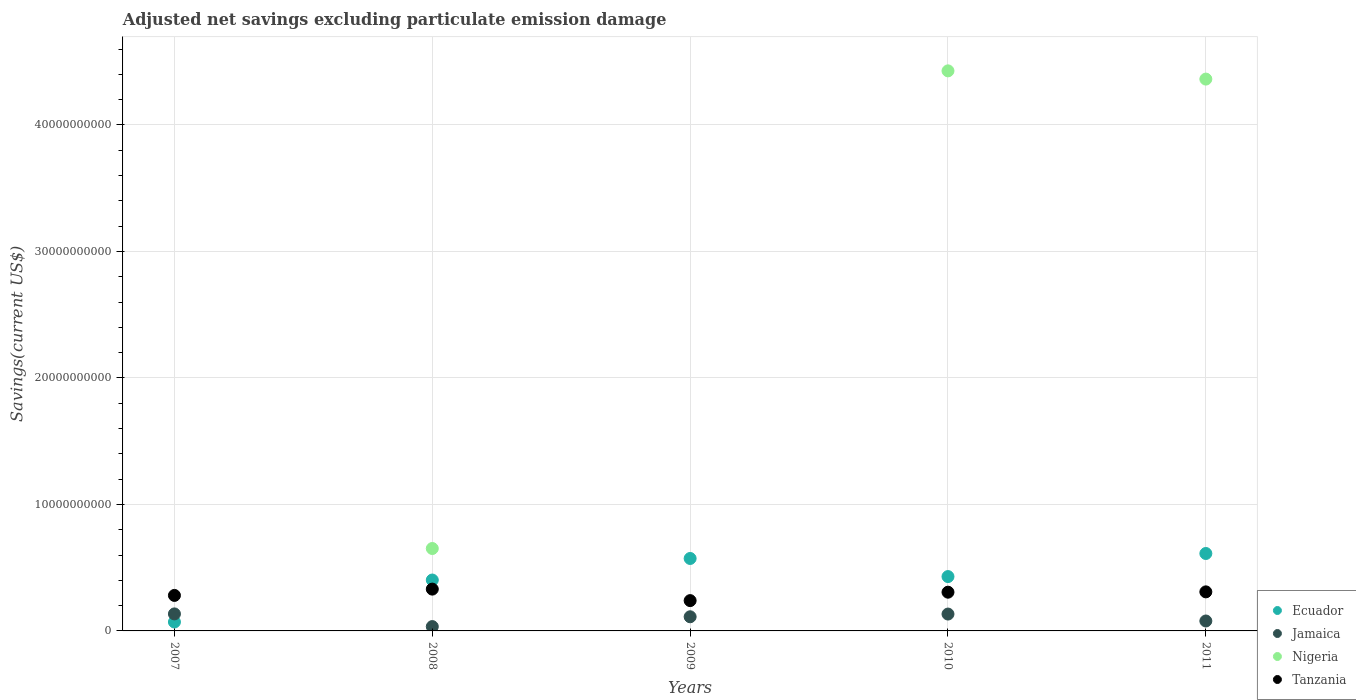Is the number of dotlines equal to the number of legend labels?
Provide a succinct answer. No. What is the adjusted net savings in Nigeria in 2011?
Make the answer very short. 4.36e+1. Across all years, what is the maximum adjusted net savings in Jamaica?
Provide a succinct answer. 1.34e+09. Across all years, what is the minimum adjusted net savings in Ecuador?
Offer a terse response. 7.05e+08. In which year was the adjusted net savings in Jamaica maximum?
Your answer should be very brief. 2007. What is the total adjusted net savings in Nigeria in the graph?
Provide a short and direct response. 9.44e+1. What is the difference between the adjusted net savings in Ecuador in 2009 and that in 2010?
Make the answer very short. 1.43e+09. What is the difference between the adjusted net savings in Ecuador in 2010 and the adjusted net savings in Tanzania in 2007?
Your answer should be very brief. 1.49e+09. What is the average adjusted net savings in Jamaica per year?
Your response must be concise. 9.85e+08. In the year 2011, what is the difference between the adjusted net savings in Tanzania and adjusted net savings in Nigeria?
Provide a short and direct response. -4.05e+1. In how many years, is the adjusted net savings in Jamaica greater than 6000000000 US$?
Provide a short and direct response. 0. What is the ratio of the adjusted net savings in Ecuador in 2007 to that in 2010?
Ensure brevity in your answer.  0.16. Is the difference between the adjusted net savings in Tanzania in 2010 and 2011 greater than the difference between the adjusted net savings in Nigeria in 2010 and 2011?
Provide a short and direct response. No. What is the difference between the highest and the second highest adjusted net savings in Jamaica?
Provide a short and direct response. 1.18e+07. What is the difference between the highest and the lowest adjusted net savings in Nigeria?
Provide a short and direct response. 4.43e+1. In how many years, is the adjusted net savings in Nigeria greater than the average adjusted net savings in Nigeria taken over all years?
Provide a short and direct response. 2. Is the sum of the adjusted net savings in Ecuador in 2007 and 2008 greater than the maximum adjusted net savings in Nigeria across all years?
Your response must be concise. No. Is it the case that in every year, the sum of the adjusted net savings in Ecuador and adjusted net savings in Jamaica  is greater than the adjusted net savings in Tanzania?
Make the answer very short. No. Does the adjusted net savings in Nigeria monotonically increase over the years?
Your response must be concise. No. Is the adjusted net savings in Tanzania strictly greater than the adjusted net savings in Jamaica over the years?
Provide a succinct answer. Yes. How many dotlines are there?
Keep it short and to the point. 4. What is the difference between two consecutive major ticks on the Y-axis?
Make the answer very short. 1.00e+1. Does the graph contain any zero values?
Keep it short and to the point. Yes. Does the graph contain grids?
Offer a terse response. Yes. Where does the legend appear in the graph?
Give a very brief answer. Bottom right. How many legend labels are there?
Provide a succinct answer. 4. How are the legend labels stacked?
Give a very brief answer. Vertical. What is the title of the graph?
Offer a terse response. Adjusted net savings excluding particulate emission damage. What is the label or title of the X-axis?
Your response must be concise. Years. What is the label or title of the Y-axis?
Your answer should be very brief. Savings(current US$). What is the Savings(current US$) of Ecuador in 2007?
Offer a terse response. 7.05e+08. What is the Savings(current US$) in Jamaica in 2007?
Give a very brief answer. 1.34e+09. What is the Savings(current US$) of Nigeria in 2007?
Offer a very short reply. 0. What is the Savings(current US$) in Tanzania in 2007?
Offer a very short reply. 2.81e+09. What is the Savings(current US$) of Ecuador in 2008?
Your response must be concise. 4.02e+09. What is the Savings(current US$) in Jamaica in 2008?
Provide a short and direct response. 3.43e+08. What is the Savings(current US$) of Nigeria in 2008?
Ensure brevity in your answer.  6.51e+09. What is the Savings(current US$) of Tanzania in 2008?
Your answer should be compact. 3.30e+09. What is the Savings(current US$) in Ecuador in 2009?
Make the answer very short. 5.73e+09. What is the Savings(current US$) in Jamaica in 2009?
Offer a very short reply. 1.12e+09. What is the Savings(current US$) of Tanzania in 2009?
Offer a very short reply. 2.40e+09. What is the Savings(current US$) of Ecuador in 2010?
Ensure brevity in your answer.  4.30e+09. What is the Savings(current US$) in Jamaica in 2010?
Provide a succinct answer. 1.33e+09. What is the Savings(current US$) of Nigeria in 2010?
Make the answer very short. 4.43e+1. What is the Savings(current US$) of Tanzania in 2010?
Offer a terse response. 3.06e+09. What is the Savings(current US$) in Ecuador in 2011?
Keep it short and to the point. 6.12e+09. What is the Savings(current US$) in Jamaica in 2011?
Your response must be concise. 7.85e+08. What is the Savings(current US$) of Nigeria in 2011?
Provide a short and direct response. 4.36e+1. What is the Savings(current US$) in Tanzania in 2011?
Give a very brief answer. 3.09e+09. Across all years, what is the maximum Savings(current US$) of Ecuador?
Provide a succinct answer. 6.12e+09. Across all years, what is the maximum Savings(current US$) of Jamaica?
Offer a very short reply. 1.34e+09. Across all years, what is the maximum Savings(current US$) in Nigeria?
Keep it short and to the point. 4.43e+1. Across all years, what is the maximum Savings(current US$) in Tanzania?
Keep it short and to the point. 3.30e+09. Across all years, what is the minimum Savings(current US$) of Ecuador?
Ensure brevity in your answer.  7.05e+08. Across all years, what is the minimum Savings(current US$) in Jamaica?
Make the answer very short. 3.43e+08. Across all years, what is the minimum Savings(current US$) in Nigeria?
Ensure brevity in your answer.  0. Across all years, what is the minimum Savings(current US$) in Tanzania?
Provide a succinct answer. 2.40e+09. What is the total Savings(current US$) of Ecuador in the graph?
Your response must be concise. 2.09e+1. What is the total Savings(current US$) of Jamaica in the graph?
Make the answer very short. 4.92e+09. What is the total Savings(current US$) in Nigeria in the graph?
Give a very brief answer. 9.44e+1. What is the total Savings(current US$) in Tanzania in the graph?
Your answer should be very brief. 1.47e+1. What is the difference between the Savings(current US$) in Ecuador in 2007 and that in 2008?
Offer a very short reply. -3.32e+09. What is the difference between the Savings(current US$) in Jamaica in 2007 and that in 2008?
Your answer should be very brief. 1.00e+09. What is the difference between the Savings(current US$) of Tanzania in 2007 and that in 2008?
Provide a short and direct response. -4.98e+08. What is the difference between the Savings(current US$) of Ecuador in 2007 and that in 2009?
Provide a succinct answer. -5.02e+09. What is the difference between the Savings(current US$) of Jamaica in 2007 and that in 2009?
Offer a very short reply. 2.26e+08. What is the difference between the Savings(current US$) in Tanzania in 2007 and that in 2009?
Offer a terse response. 4.11e+08. What is the difference between the Savings(current US$) of Ecuador in 2007 and that in 2010?
Your answer should be very brief. -3.59e+09. What is the difference between the Savings(current US$) of Jamaica in 2007 and that in 2010?
Your answer should be very brief. 1.18e+07. What is the difference between the Savings(current US$) in Tanzania in 2007 and that in 2010?
Offer a very short reply. -2.55e+08. What is the difference between the Savings(current US$) in Ecuador in 2007 and that in 2011?
Offer a terse response. -5.42e+09. What is the difference between the Savings(current US$) of Jamaica in 2007 and that in 2011?
Your response must be concise. 5.60e+08. What is the difference between the Savings(current US$) in Tanzania in 2007 and that in 2011?
Ensure brevity in your answer.  -2.81e+08. What is the difference between the Savings(current US$) in Ecuador in 2008 and that in 2009?
Your response must be concise. -1.70e+09. What is the difference between the Savings(current US$) of Jamaica in 2008 and that in 2009?
Your answer should be very brief. -7.75e+08. What is the difference between the Savings(current US$) of Tanzania in 2008 and that in 2009?
Provide a succinct answer. 9.09e+08. What is the difference between the Savings(current US$) of Ecuador in 2008 and that in 2010?
Offer a terse response. -2.72e+08. What is the difference between the Savings(current US$) of Jamaica in 2008 and that in 2010?
Your response must be concise. -9.90e+08. What is the difference between the Savings(current US$) of Nigeria in 2008 and that in 2010?
Make the answer very short. -3.78e+1. What is the difference between the Savings(current US$) of Tanzania in 2008 and that in 2010?
Your answer should be very brief. 2.43e+08. What is the difference between the Savings(current US$) in Ecuador in 2008 and that in 2011?
Your answer should be compact. -2.10e+09. What is the difference between the Savings(current US$) of Jamaica in 2008 and that in 2011?
Provide a succinct answer. -4.42e+08. What is the difference between the Savings(current US$) of Nigeria in 2008 and that in 2011?
Provide a short and direct response. -3.71e+1. What is the difference between the Savings(current US$) of Tanzania in 2008 and that in 2011?
Provide a short and direct response. 2.18e+08. What is the difference between the Savings(current US$) of Ecuador in 2009 and that in 2010?
Your response must be concise. 1.43e+09. What is the difference between the Savings(current US$) of Jamaica in 2009 and that in 2010?
Offer a terse response. -2.14e+08. What is the difference between the Savings(current US$) in Tanzania in 2009 and that in 2010?
Give a very brief answer. -6.66e+08. What is the difference between the Savings(current US$) of Ecuador in 2009 and that in 2011?
Offer a very short reply. -3.94e+08. What is the difference between the Savings(current US$) of Jamaica in 2009 and that in 2011?
Offer a terse response. 3.34e+08. What is the difference between the Savings(current US$) of Tanzania in 2009 and that in 2011?
Provide a short and direct response. -6.91e+08. What is the difference between the Savings(current US$) of Ecuador in 2010 and that in 2011?
Ensure brevity in your answer.  -1.82e+09. What is the difference between the Savings(current US$) of Jamaica in 2010 and that in 2011?
Keep it short and to the point. 5.48e+08. What is the difference between the Savings(current US$) of Nigeria in 2010 and that in 2011?
Keep it short and to the point. 6.51e+08. What is the difference between the Savings(current US$) in Tanzania in 2010 and that in 2011?
Give a very brief answer. -2.55e+07. What is the difference between the Savings(current US$) of Ecuador in 2007 and the Savings(current US$) of Jamaica in 2008?
Your answer should be very brief. 3.61e+08. What is the difference between the Savings(current US$) of Ecuador in 2007 and the Savings(current US$) of Nigeria in 2008?
Offer a terse response. -5.81e+09. What is the difference between the Savings(current US$) of Ecuador in 2007 and the Savings(current US$) of Tanzania in 2008?
Make the answer very short. -2.60e+09. What is the difference between the Savings(current US$) of Jamaica in 2007 and the Savings(current US$) of Nigeria in 2008?
Your response must be concise. -5.17e+09. What is the difference between the Savings(current US$) of Jamaica in 2007 and the Savings(current US$) of Tanzania in 2008?
Make the answer very short. -1.96e+09. What is the difference between the Savings(current US$) in Ecuador in 2007 and the Savings(current US$) in Jamaica in 2009?
Offer a terse response. -4.14e+08. What is the difference between the Savings(current US$) in Ecuador in 2007 and the Savings(current US$) in Tanzania in 2009?
Provide a succinct answer. -1.69e+09. What is the difference between the Savings(current US$) of Jamaica in 2007 and the Savings(current US$) of Tanzania in 2009?
Your answer should be very brief. -1.05e+09. What is the difference between the Savings(current US$) of Ecuador in 2007 and the Savings(current US$) of Jamaica in 2010?
Give a very brief answer. -6.28e+08. What is the difference between the Savings(current US$) of Ecuador in 2007 and the Savings(current US$) of Nigeria in 2010?
Ensure brevity in your answer.  -4.36e+1. What is the difference between the Savings(current US$) in Ecuador in 2007 and the Savings(current US$) in Tanzania in 2010?
Provide a short and direct response. -2.36e+09. What is the difference between the Savings(current US$) in Jamaica in 2007 and the Savings(current US$) in Nigeria in 2010?
Offer a very short reply. -4.29e+1. What is the difference between the Savings(current US$) of Jamaica in 2007 and the Savings(current US$) of Tanzania in 2010?
Keep it short and to the point. -1.72e+09. What is the difference between the Savings(current US$) in Ecuador in 2007 and the Savings(current US$) in Jamaica in 2011?
Make the answer very short. -8.03e+07. What is the difference between the Savings(current US$) of Ecuador in 2007 and the Savings(current US$) of Nigeria in 2011?
Give a very brief answer. -4.29e+1. What is the difference between the Savings(current US$) in Ecuador in 2007 and the Savings(current US$) in Tanzania in 2011?
Give a very brief answer. -2.38e+09. What is the difference between the Savings(current US$) in Jamaica in 2007 and the Savings(current US$) in Nigeria in 2011?
Provide a short and direct response. -4.23e+1. What is the difference between the Savings(current US$) of Jamaica in 2007 and the Savings(current US$) of Tanzania in 2011?
Provide a succinct answer. -1.74e+09. What is the difference between the Savings(current US$) in Ecuador in 2008 and the Savings(current US$) in Jamaica in 2009?
Offer a terse response. 2.90e+09. What is the difference between the Savings(current US$) of Ecuador in 2008 and the Savings(current US$) of Tanzania in 2009?
Provide a short and direct response. 1.63e+09. What is the difference between the Savings(current US$) of Jamaica in 2008 and the Savings(current US$) of Tanzania in 2009?
Give a very brief answer. -2.05e+09. What is the difference between the Savings(current US$) in Nigeria in 2008 and the Savings(current US$) in Tanzania in 2009?
Offer a very short reply. 4.12e+09. What is the difference between the Savings(current US$) in Ecuador in 2008 and the Savings(current US$) in Jamaica in 2010?
Provide a short and direct response. 2.69e+09. What is the difference between the Savings(current US$) in Ecuador in 2008 and the Savings(current US$) in Nigeria in 2010?
Ensure brevity in your answer.  -4.02e+1. What is the difference between the Savings(current US$) in Ecuador in 2008 and the Savings(current US$) in Tanzania in 2010?
Ensure brevity in your answer.  9.62e+08. What is the difference between the Savings(current US$) of Jamaica in 2008 and the Savings(current US$) of Nigeria in 2010?
Your answer should be very brief. -4.39e+1. What is the difference between the Savings(current US$) of Jamaica in 2008 and the Savings(current US$) of Tanzania in 2010?
Make the answer very short. -2.72e+09. What is the difference between the Savings(current US$) in Nigeria in 2008 and the Savings(current US$) in Tanzania in 2010?
Provide a short and direct response. 3.45e+09. What is the difference between the Savings(current US$) in Ecuador in 2008 and the Savings(current US$) in Jamaica in 2011?
Your answer should be very brief. 3.24e+09. What is the difference between the Savings(current US$) in Ecuador in 2008 and the Savings(current US$) in Nigeria in 2011?
Offer a terse response. -3.96e+1. What is the difference between the Savings(current US$) of Ecuador in 2008 and the Savings(current US$) of Tanzania in 2011?
Ensure brevity in your answer.  9.36e+08. What is the difference between the Savings(current US$) of Jamaica in 2008 and the Savings(current US$) of Nigeria in 2011?
Your response must be concise. -4.33e+1. What is the difference between the Savings(current US$) in Jamaica in 2008 and the Savings(current US$) in Tanzania in 2011?
Ensure brevity in your answer.  -2.74e+09. What is the difference between the Savings(current US$) in Nigeria in 2008 and the Savings(current US$) in Tanzania in 2011?
Ensure brevity in your answer.  3.43e+09. What is the difference between the Savings(current US$) of Ecuador in 2009 and the Savings(current US$) of Jamaica in 2010?
Make the answer very short. 4.39e+09. What is the difference between the Savings(current US$) of Ecuador in 2009 and the Savings(current US$) of Nigeria in 2010?
Your answer should be very brief. -3.85e+1. What is the difference between the Savings(current US$) in Ecuador in 2009 and the Savings(current US$) in Tanzania in 2010?
Your response must be concise. 2.67e+09. What is the difference between the Savings(current US$) of Jamaica in 2009 and the Savings(current US$) of Nigeria in 2010?
Give a very brief answer. -4.32e+1. What is the difference between the Savings(current US$) of Jamaica in 2009 and the Savings(current US$) of Tanzania in 2010?
Ensure brevity in your answer.  -1.94e+09. What is the difference between the Savings(current US$) of Ecuador in 2009 and the Savings(current US$) of Jamaica in 2011?
Keep it short and to the point. 4.94e+09. What is the difference between the Savings(current US$) in Ecuador in 2009 and the Savings(current US$) in Nigeria in 2011?
Keep it short and to the point. -3.79e+1. What is the difference between the Savings(current US$) in Ecuador in 2009 and the Savings(current US$) in Tanzania in 2011?
Keep it short and to the point. 2.64e+09. What is the difference between the Savings(current US$) of Jamaica in 2009 and the Savings(current US$) of Nigeria in 2011?
Your response must be concise. -4.25e+1. What is the difference between the Savings(current US$) in Jamaica in 2009 and the Savings(current US$) in Tanzania in 2011?
Offer a terse response. -1.97e+09. What is the difference between the Savings(current US$) in Ecuador in 2010 and the Savings(current US$) in Jamaica in 2011?
Your answer should be compact. 3.51e+09. What is the difference between the Savings(current US$) in Ecuador in 2010 and the Savings(current US$) in Nigeria in 2011?
Offer a very short reply. -3.93e+1. What is the difference between the Savings(current US$) of Ecuador in 2010 and the Savings(current US$) of Tanzania in 2011?
Provide a short and direct response. 1.21e+09. What is the difference between the Savings(current US$) in Jamaica in 2010 and the Savings(current US$) in Nigeria in 2011?
Keep it short and to the point. -4.23e+1. What is the difference between the Savings(current US$) in Jamaica in 2010 and the Savings(current US$) in Tanzania in 2011?
Your answer should be compact. -1.75e+09. What is the difference between the Savings(current US$) of Nigeria in 2010 and the Savings(current US$) of Tanzania in 2011?
Your answer should be compact. 4.12e+1. What is the average Savings(current US$) of Ecuador per year?
Keep it short and to the point. 4.17e+09. What is the average Savings(current US$) in Jamaica per year?
Offer a terse response. 9.85e+08. What is the average Savings(current US$) in Nigeria per year?
Make the answer very short. 1.89e+1. What is the average Savings(current US$) of Tanzania per year?
Offer a terse response. 2.93e+09. In the year 2007, what is the difference between the Savings(current US$) in Ecuador and Savings(current US$) in Jamaica?
Provide a short and direct response. -6.40e+08. In the year 2007, what is the difference between the Savings(current US$) of Ecuador and Savings(current US$) of Tanzania?
Make the answer very short. -2.10e+09. In the year 2007, what is the difference between the Savings(current US$) of Jamaica and Savings(current US$) of Tanzania?
Your answer should be very brief. -1.46e+09. In the year 2008, what is the difference between the Savings(current US$) in Ecuador and Savings(current US$) in Jamaica?
Make the answer very short. 3.68e+09. In the year 2008, what is the difference between the Savings(current US$) of Ecuador and Savings(current US$) of Nigeria?
Your answer should be compact. -2.49e+09. In the year 2008, what is the difference between the Savings(current US$) in Ecuador and Savings(current US$) in Tanzania?
Your answer should be very brief. 7.19e+08. In the year 2008, what is the difference between the Savings(current US$) in Jamaica and Savings(current US$) in Nigeria?
Your answer should be compact. -6.17e+09. In the year 2008, what is the difference between the Savings(current US$) in Jamaica and Savings(current US$) in Tanzania?
Your answer should be compact. -2.96e+09. In the year 2008, what is the difference between the Savings(current US$) in Nigeria and Savings(current US$) in Tanzania?
Keep it short and to the point. 3.21e+09. In the year 2009, what is the difference between the Savings(current US$) of Ecuador and Savings(current US$) of Jamaica?
Your answer should be very brief. 4.61e+09. In the year 2009, what is the difference between the Savings(current US$) in Ecuador and Savings(current US$) in Tanzania?
Ensure brevity in your answer.  3.33e+09. In the year 2009, what is the difference between the Savings(current US$) of Jamaica and Savings(current US$) of Tanzania?
Offer a terse response. -1.28e+09. In the year 2010, what is the difference between the Savings(current US$) of Ecuador and Savings(current US$) of Jamaica?
Your response must be concise. 2.96e+09. In the year 2010, what is the difference between the Savings(current US$) of Ecuador and Savings(current US$) of Nigeria?
Your response must be concise. -4.00e+1. In the year 2010, what is the difference between the Savings(current US$) of Ecuador and Savings(current US$) of Tanzania?
Give a very brief answer. 1.23e+09. In the year 2010, what is the difference between the Savings(current US$) of Jamaica and Savings(current US$) of Nigeria?
Keep it short and to the point. -4.29e+1. In the year 2010, what is the difference between the Savings(current US$) in Jamaica and Savings(current US$) in Tanzania?
Provide a short and direct response. -1.73e+09. In the year 2010, what is the difference between the Savings(current US$) of Nigeria and Savings(current US$) of Tanzania?
Your answer should be compact. 4.12e+1. In the year 2011, what is the difference between the Savings(current US$) in Ecuador and Savings(current US$) in Jamaica?
Your answer should be very brief. 5.34e+09. In the year 2011, what is the difference between the Savings(current US$) of Ecuador and Savings(current US$) of Nigeria?
Your answer should be compact. -3.75e+1. In the year 2011, what is the difference between the Savings(current US$) in Ecuador and Savings(current US$) in Tanzania?
Provide a succinct answer. 3.03e+09. In the year 2011, what is the difference between the Savings(current US$) of Jamaica and Savings(current US$) of Nigeria?
Keep it short and to the point. -4.28e+1. In the year 2011, what is the difference between the Savings(current US$) of Jamaica and Savings(current US$) of Tanzania?
Offer a very short reply. -2.30e+09. In the year 2011, what is the difference between the Savings(current US$) of Nigeria and Savings(current US$) of Tanzania?
Ensure brevity in your answer.  4.05e+1. What is the ratio of the Savings(current US$) in Ecuador in 2007 to that in 2008?
Make the answer very short. 0.18. What is the ratio of the Savings(current US$) of Jamaica in 2007 to that in 2008?
Your answer should be very brief. 3.92. What is the ratio of the Savings(current US$) of Tanzania in 2007 to that in 2008?
Keep it short and to the point. 0.85. What is the ratio of the Savings(current US$) of Ecuador in 2007 to that in 2009?
Your response must be concise. 0.12. What is the ratio of the Savings(current US$) in Jamaica in 2007 to that in 2009?
Keep it short and to the point. 1.2. What is the ratio of the Savings(current US$) of Tanzania in 2007 to that in 2009?
Provide a succinct answer. 1.17. What is the ratio of the Savings(current US$) of Ecuador in 2007 to that in 2010?
Your answer should be very brief. 0.16. What is the ratio of the Savings(current US$) in Jamaica in 2007 to that in 2010?
Your answer should be compact. 1.01. What is the ratio of the Savings(current US$) of Tanzania in 2007 to that in 2010?
Provide a short and direct response. 0.92. What is the ratio of the Savings(current US$) in Ecuador in 2007 to that in 2011?
Make the answer very short. 0.12. What is the ratio of the Savings(current US$) of Jamaica in 2007 to that in 2011?
Your answer should be compact. 1.71. What is the ratio of the Savings(current US$) of Ecuador in 2008 to that in 2009?
Your response must be concise. 0.7. What is the ratio of the Savings(current US$) in Jamaica in 2008 to that in 2009?
Offer a very short reply. 0.31. What is the ratio of the Savings(current US$) of Tanzania in 2008 to that in 2009?
Your answer should be very brief. 1.38. What is the ratio of the Savings(current US$) in Ecuador in 2008 to that in 2010?
Give a very brief answer. 0.94. What is the ratio of the Savings(current US$) of Jamaica in 2008 to that in 2010?
Offer a very short reply. 0.26. What is the ratio of the Savings(current US$) in Nigeria in 2008 to that in 2010?
Offer a terse response. 0.15. What is the ratio of the Savings(current US$) in Tanzania in 2008 to that in 2010?
Ensure brevity in your answer.  1.08. What is the ratio of the Savings(current US$) of Ecuador in 2008 to that in 2011?
Give a very brief answer. 0.66. What is the ratio of the Savings(current US$) of Jamaica in 2008 to that in 2011?
Provide a succinct answer. 0.44. What is the ratio of the Savings(current US$) of Nigeria in 2008 to that in 2011?
Make the answer very short. 0.15. What is the ratio of the Savings(current US$) of Tanzania in 2008 to that in 2011?
Offer a very short reply. 1.07. What is the ratio of the Savings(current US$) of Ecuador in 2009 to that in 2010?
Make the answer very short. 1.33. What is the ratio of the Savings(current US$) in Jamaica in 2009 to that in 2010?
Ensure brevity in your answer.  0.84. What is the ratio of the Savings(current US$) in Tanzania in 2009 to that in 2010?
Make the answer very short. 0.78. What is the ratio of the Savings(current US$) in Ecuador in 2009 to that in 2011?
Your answer should be very brief. 0.94. What is the ratio of the Savings(current US$) in Jamaica in 2009 to that in 2011?
Your answer should be compact. 1.43. What is the ratio of the Savings(current US$) of Tanzania in 2009 to that in 2011?
Make the answer very short. 0.78. What is the ratio of the Savings(current US$) of Ecuador in 2010 to that in 2011?
Give a very brief answer. 0.7. What is the ratio of the Savings(current US$) of Jamaica in 2010 to that in 2011?
Offer a very short reply. 1.7. What is the ratio of the Savings(current US$) in Nigeria in 2010 to that in 2011?
Your answer should be compact. 1.01. What is the difference between the highest and the second highest Savings(current US$) of Ecuador?
Your answer should be very brief. 3.94e+08. What is the difference between the highest and the second highest Savings(current US$) of Jamaica?
Your answer should be compact. 1.18e+07. What is the difference between the highest and the second highest Savings(current US$) of Nigeria?
Ensure brevity in your answer.  6.51e+08. What is the difference between the highest and the second highest Savings(current US$) in Tanzania?
Your answer should be compact. 2.18e+08. What is the difference between the highest and the lowest Savings(current US$) of Ecuador?
Give a very brief answer. 5.42e+09. What is the difference between the highest and the lowest Savings(current US$) in Jamaica?
Make the answer very short. 1.00e+09. What is the difference between the highest and the lowest Savings(current US$) of Nigeria?
Ensure brevity in your answer.  4.43e+1. What is the difference between the highest and the lowest Savings(current US$) in Tanzania?
Ensure brevity in your answer.  9.09e+08. 